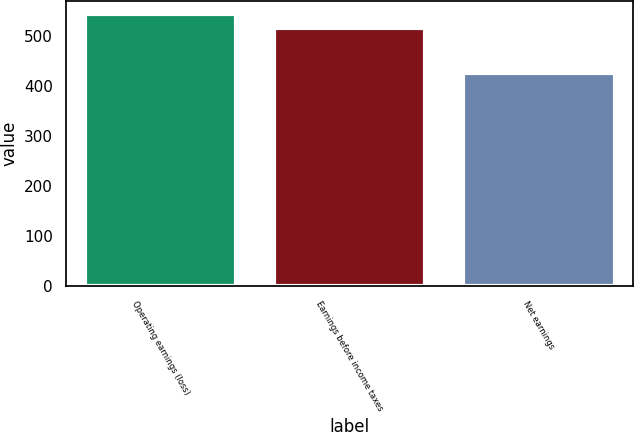<chart> <loc_0><loc_0><loc_500><loc_500><bar_chart><fcel>Operating earnings (loss)<fcel>Earnings before income taxes<fcel>Net earnings<nl><fcel>543.5<fcel>516.9<fcel>425.4<nl></chart> 